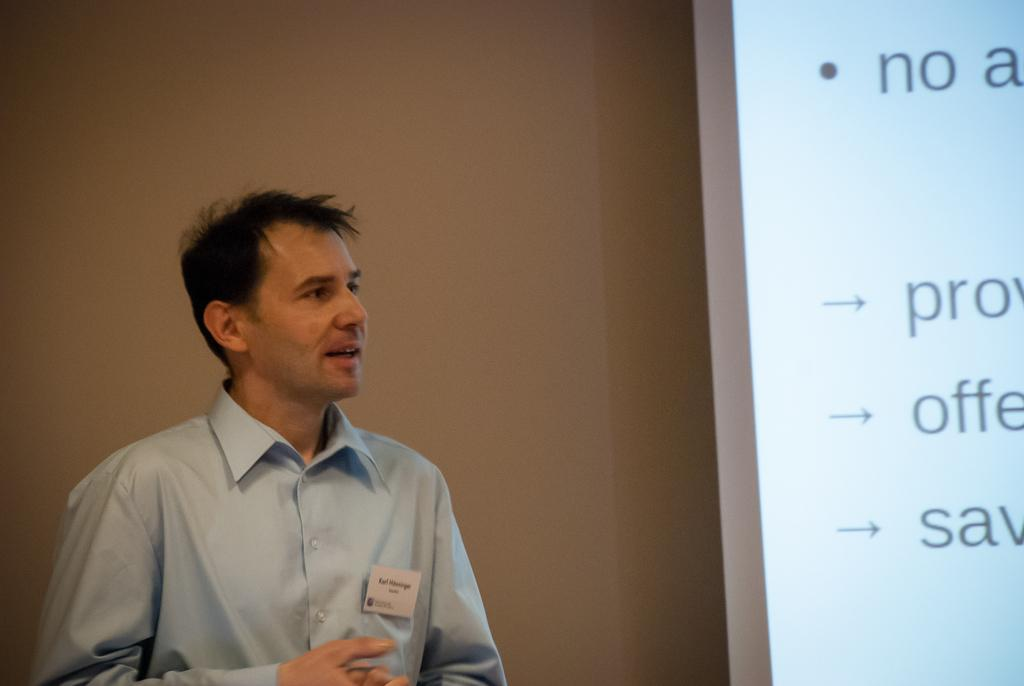What is the man in the image doing? The man is standing and speaking in the image. Where is the man located in the image? The man is in the front of the image. What can be seen on the right side of the image? There is a screen on the right side of the image. What is displayed on the screen? There are texts visible on the screen. What type of coal is being used to fuel the tank in the image? There is no tank or coal present in the image. What emotion is the man expressing towards the texts on the screen? The image does not provide information about the man's emotions or feelings towards the texts on the screen. 